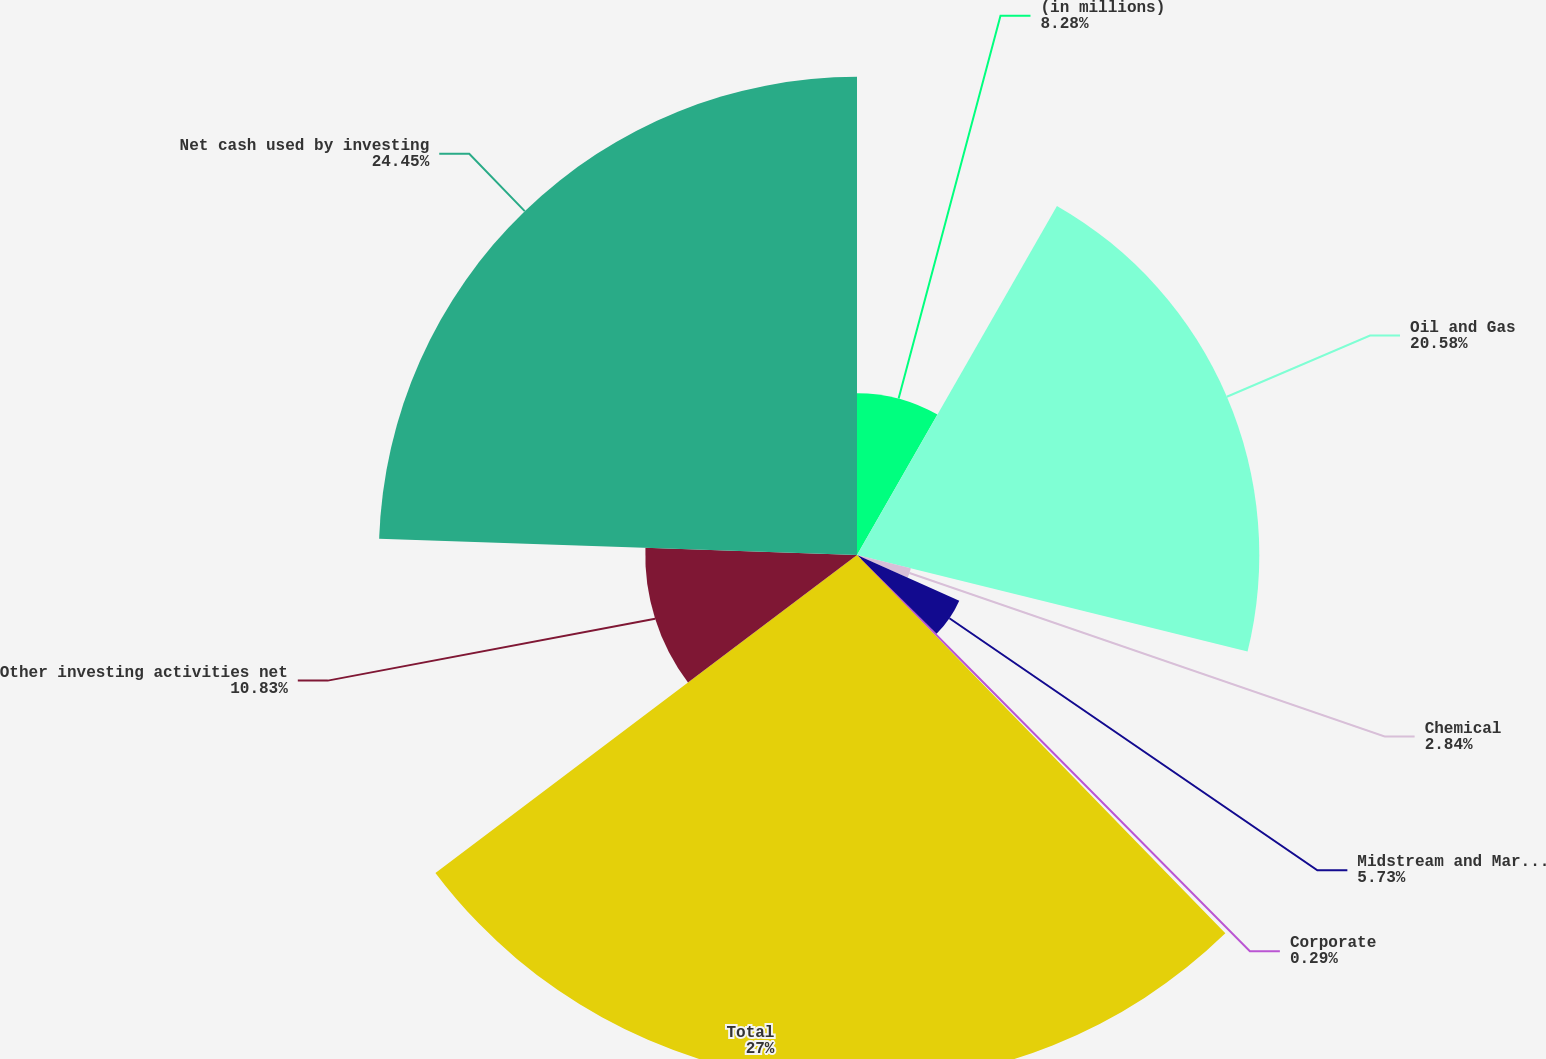<chart> <loc_0><loc_0><loc_500><loc_500><pie_chart><fcel>(in millions)<fcel>Oil and Gas<fcel>Chemical<fcel>Midstream and Marketing<fcel>Corporate<fcel>Total<fcel>Other investing activities net<fcel>Net cash used by investing<nl><fcel>8.28%<fcel>20.58%<fcel>2.84%<fcel>5.73%<fcel>0.29%<fcel>27.01%<fcel>10.83%<fcel>24.46%<nl></chart> 